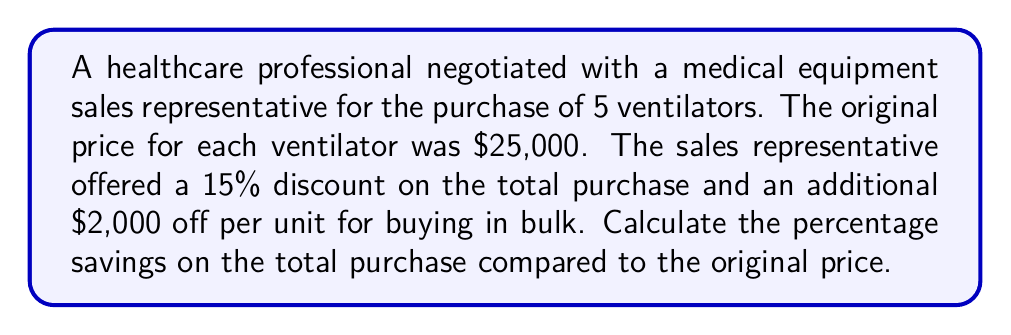Solve this math problem. Let's approach this problem step-by-step:

1. Calculate the original total price:
   $$\text{Original Price} = 5 \times \$25,000 = \$125,000$$

2. Calculate the discount amount from the 15% offer:
   $$\text{15% Discount} = 0.15 \times \$125,000 = \$18,750$$

3. Calculate the additional bulk purchase discount:
   $$\text{Bulk Discount} = 5 \times \$2,000 = \$10,000$$

4. Calculate the total discount:
   $$\text{Total Discount} = \$18,750 + \$10,000 = \$28,750$$

5. Calculate the final price:
   $$\text{Final Price} = \$125,000 - \$28,750 = \$96,250$$

6. Calculate the percentage savings:
   $$\text{Percentage Savings} = \frac{\text{Total Discount}}{\text{Original Price}} \times 100\%$$
   $$= \frac{\$28,750}{\$125,000} \times 100\%$$
   $$= 0.23 \times 100\% = 23\%$$

Therefore, the healthcare professional saved 23% on the total purchase compared to the original price.
Answer: 23% 